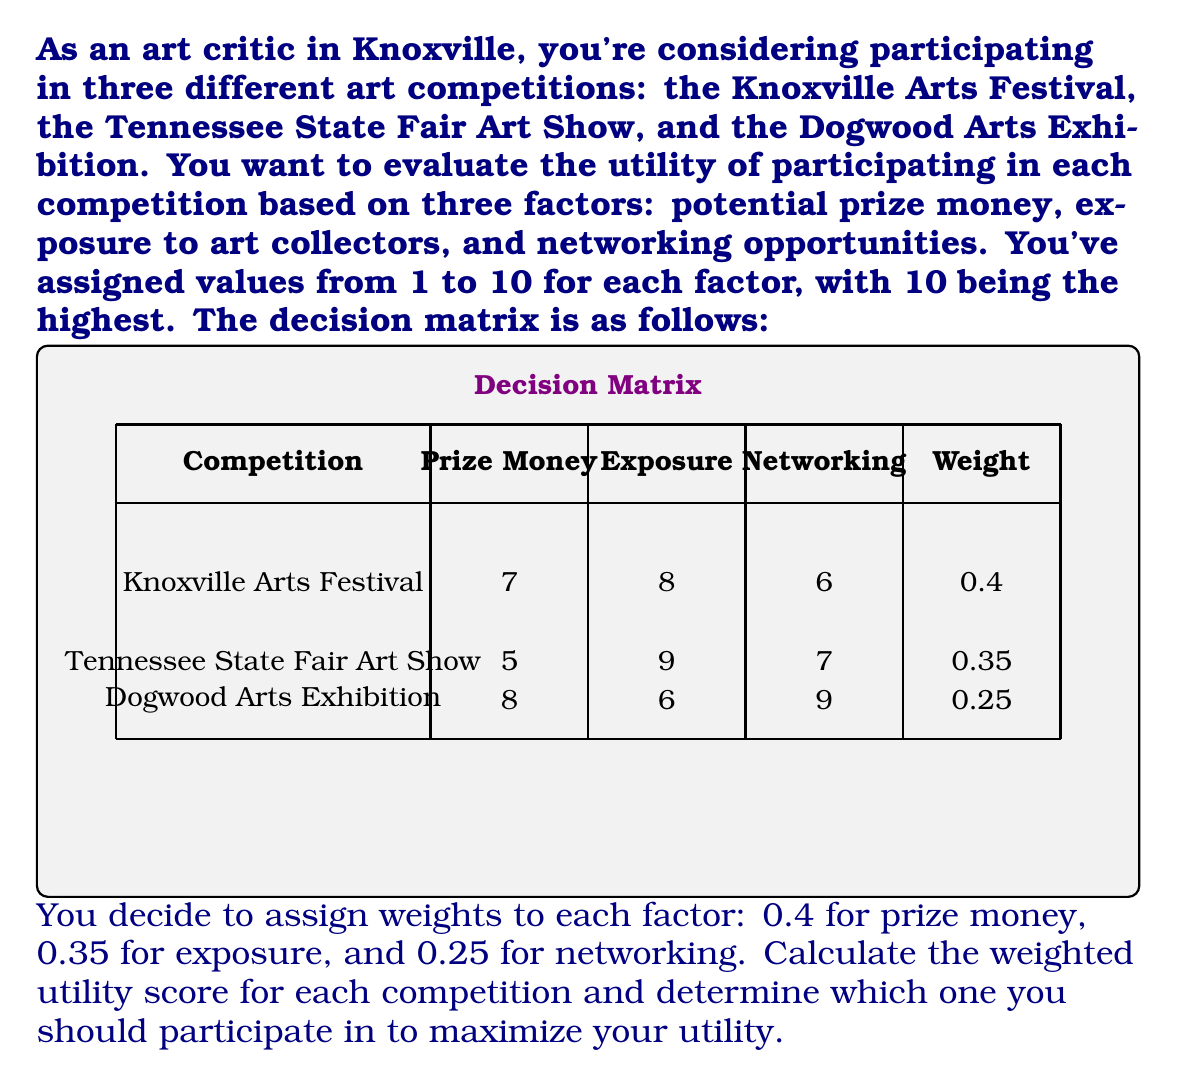Provide a solution to this math problem. To solve this problem, we'll follow these steps:

1. Calculate the weighted score for each factor in each competition.
2. Sum the weighted scores for each competition to get the total utility score.
3. Compare the total utility scores to determine the best competition.

Let's start with the calculations:

1. Knoxville Arts Festival:
   Prize Money: $0.4 \times 7 = 2.8$
   Exposure: $0.35 \times 8 = 2.8$
   Networking: $0.25 \times 6 = 1.5$
   Total: $2.8 + 2.8 + 1.5 = 7.1$

2. Tennessee State Fair Art Show:
   Prize Money: $0.4 \times 5 = 2.0$
   Exposure: $0.35 \times 9 = 3.15$
   Networking: $0.25 \times 7 = 1.75$
   Total: $2.0 + 3.15 + 1.75 = 6.9$

3. Dogwood Arts Exhibition:
   Prize Money: $0.4 \times 8 = 3.2$
   Exposure: $0.35 \times 6 = 2.1$
   Networking: $0.25 \times 9 = 2.25$
   Total: $3.2 + 2.1 + 2.25 = 7.55$

Comparing the total utility scores:
Knoxville Arts Festival: 7.1
Tennessee State Fair Art Show: 6.9
Dogwood Arts Exhibition: 7.55

The Dogwood Arts Exhibition has the highest utility score of 7.55, so this is the competition you should participate in to maximize your utility.
Answer: Dogwood Arts Exhibition (utility score: 7.55) 